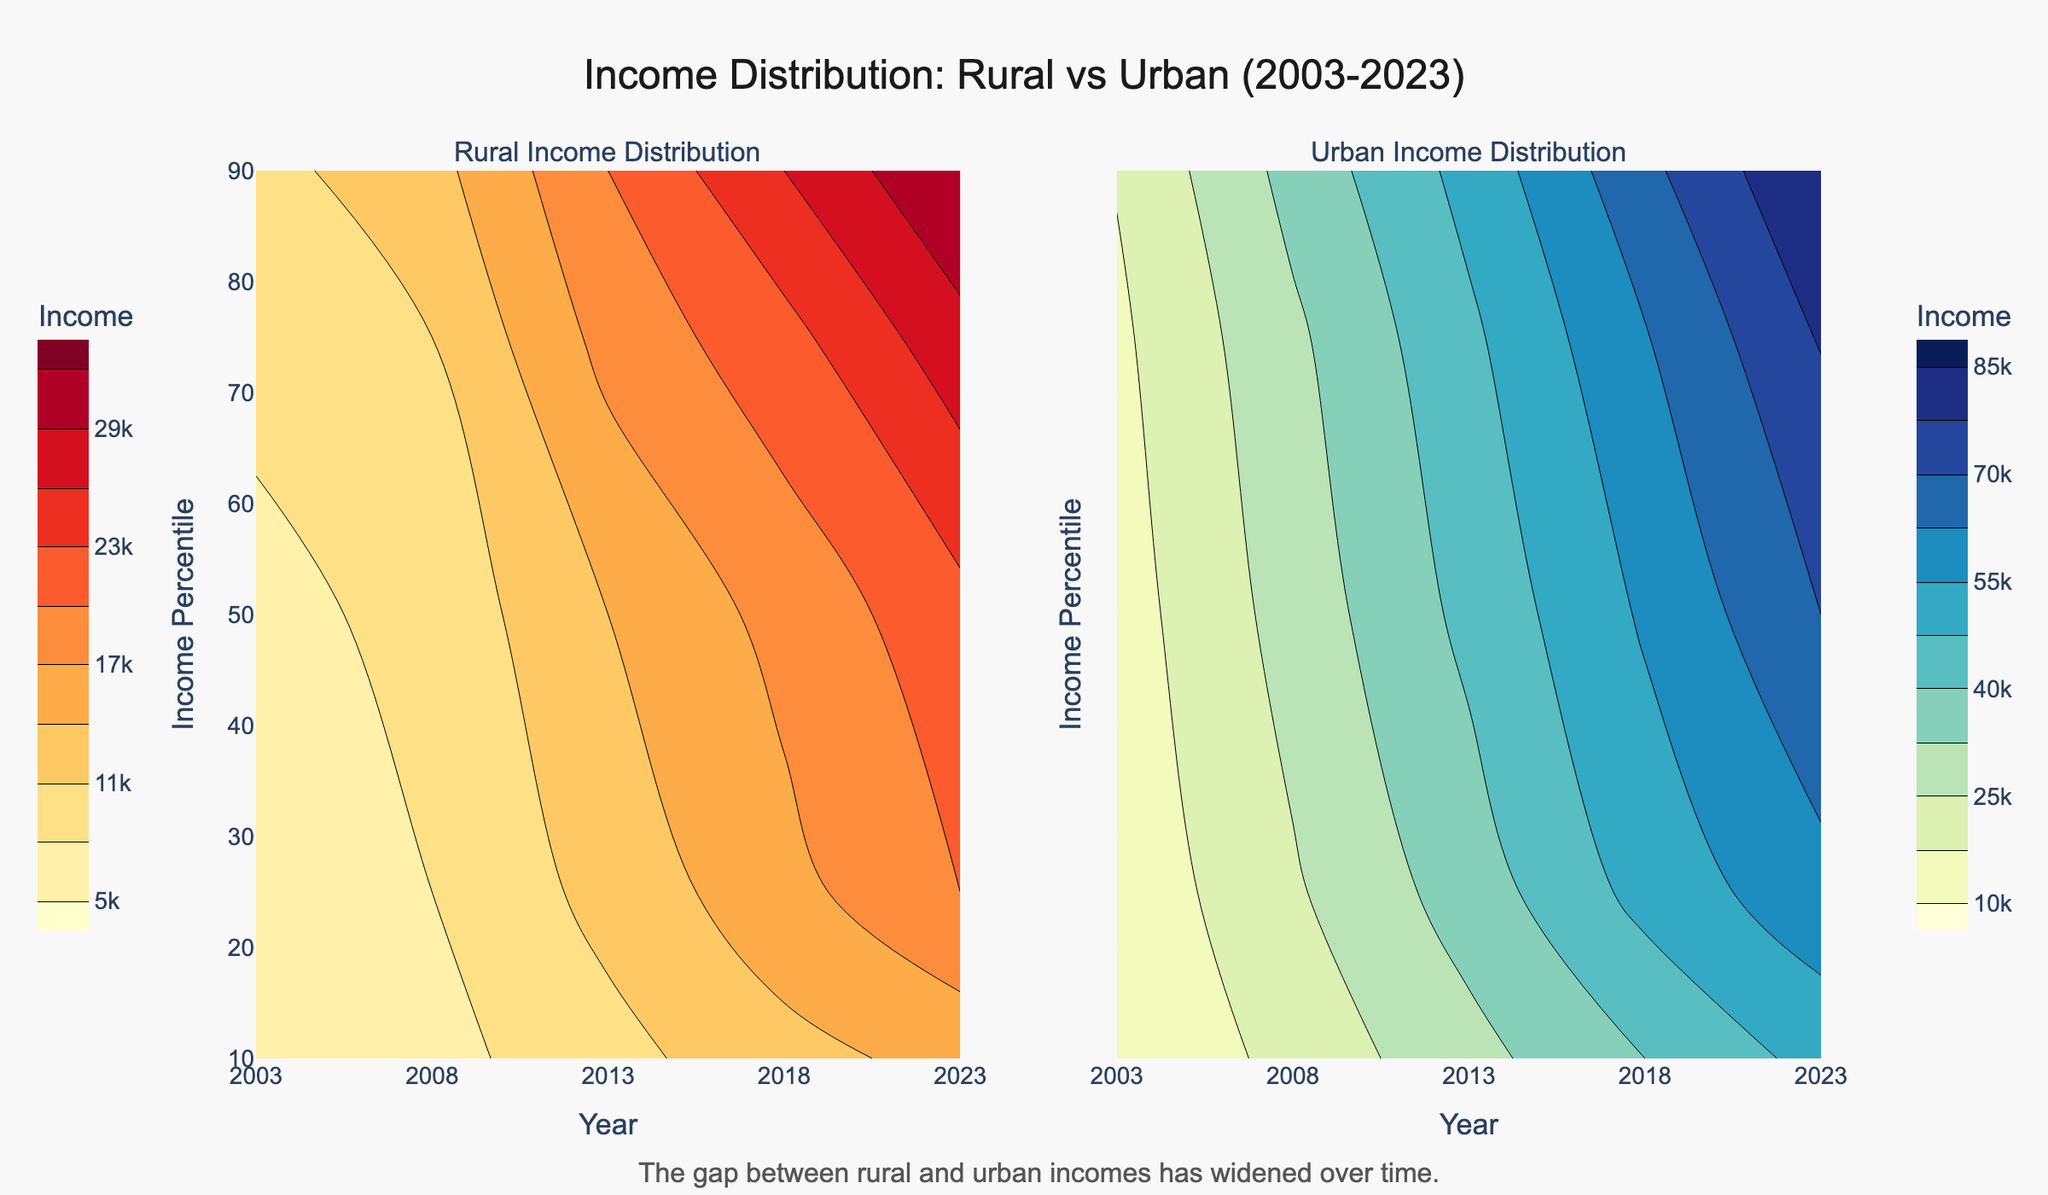What is the title of the figure? The title is displayed at the top of the figure.
Answer: Income Distribution: Rural vs Urban (2003-2023) Which area has a higher income for the 50th percentile in the year 2023? Look at the contour lines for the 50th percentile in 2023 for both rural and urban areas. Compare the income values at that percentile.
Answer: Urban How did the average income for the 75th percentile change in rural areas from 2003 to 2023? Locate the contour lines for the 75th percentile in rural areas for the years 2003 and 2023. Subtract the income value in 2003 from the income value in 2023.
Answer: Increased by 13,000 Compare the income distribution in urban areas between 2003 and 2023. Where is the increase more prominent, at lower or higher percentiles? Examine the contour lines for urban areas for both years across all percentiles. Notice how the income values change, especially at different percentiles.
Answer: Higher percentiles What is the difference in average income for the 25th percentile between urban and rural areas in 2013? Find the contour lines for the 25th percentile in both urban and rural areas for the year 2013. Subtract the rural value from the urban value.
Answer: 19,000 How does the income gap between the 90th percentile and 10th percentile change in rural areas from 2003 to 2023? Calculate the difference between the 90th and 10th percentile incomes for the years 2003 and 2023 in rural areas. Compare these differences to understand the change.
Answer: Increased by 8,000 What colors are used to represent income levels in rural and urban areas? Observe the color scales used in the contour plots for rural and urban areas. 'YlOrRd' is used for rural and 'YlGnBu' is used for urban.
Answer: Yellow-Orange-Red for rural, Yellow-Green-Blue for urban Between which years is the most significant increase in average income observed for the 75th percentile in urban areas? Examine the contour lines for the 75th percentile in urban areas across all years. Identify the years with the steepest gradient or largest income increase.
Answer: 2008 to 2013 What annotation is included in the figure? Check for any text annotations added outside the main plot areas.
Answer: The gap between rural and urban incomes has widened over time 